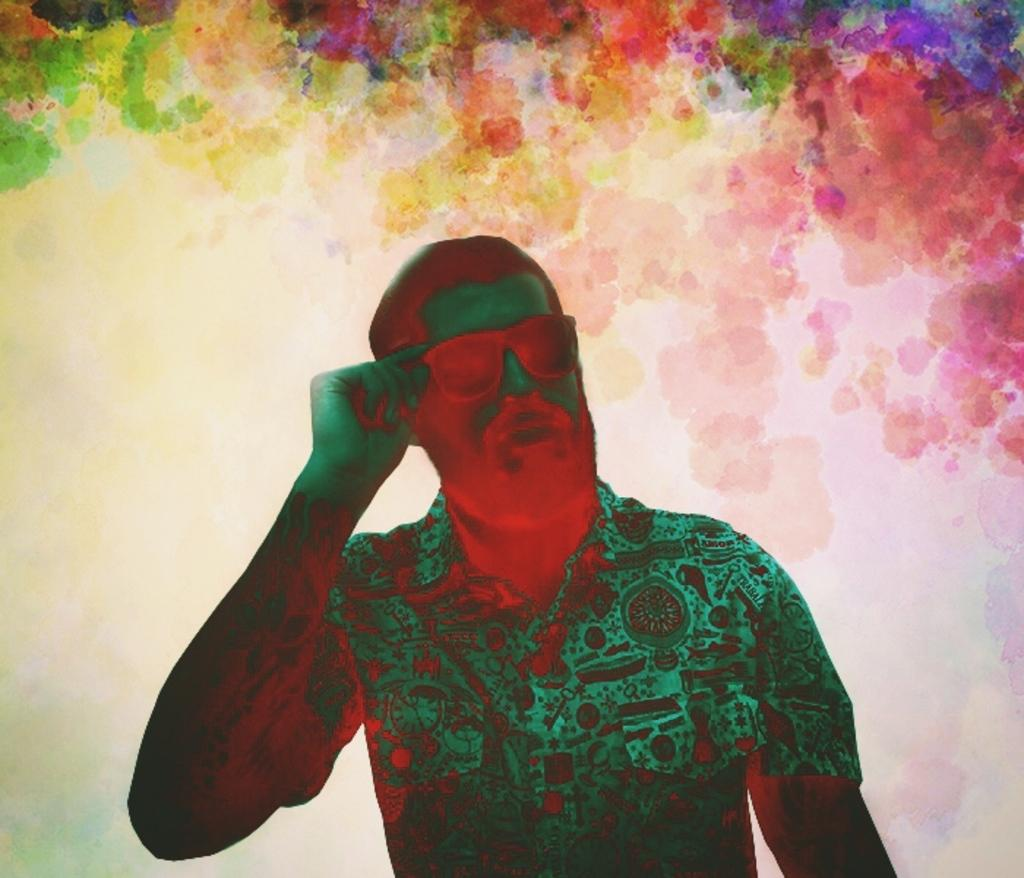What is the main subject of the image? There is a person standing in the middle of the image. Can you describe the background of the image? The background of the image has different colors. What type of relation does the person have with the system in the image? There is no system present in the image, so it is not possible to determine any relation between the person and a system. 